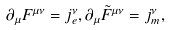<formula> <loc_0><loc_0><loc_500><loc_500>\partial _ { \mu } F ^ { \mu \nu } = j _ { e } ^ { \nu } , \partial _ { \mu } \tilde { F } ^ { \mu \nu } = j ^ { \nu } _ { m } ,</formula> 